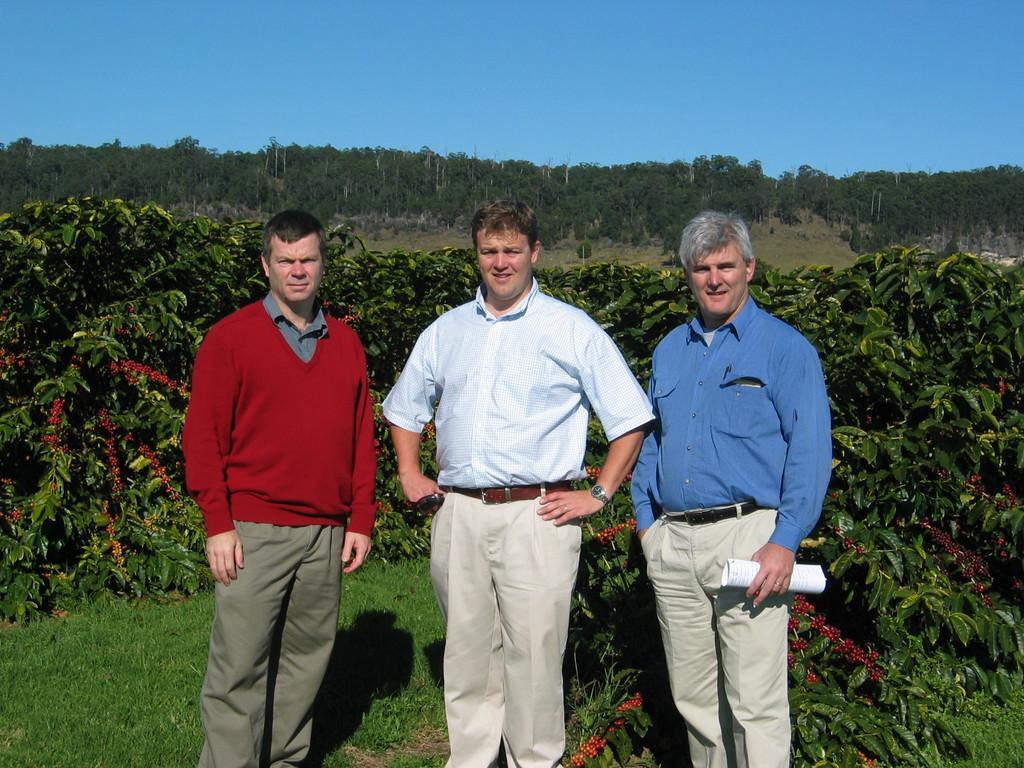Could you give a brief overview of what you see in this image? In this image we can see three men standing on the ground. In that a man is holding a paper. We can also see some grass, a group of plants, a group of trees and the sky which looks cloudy. 